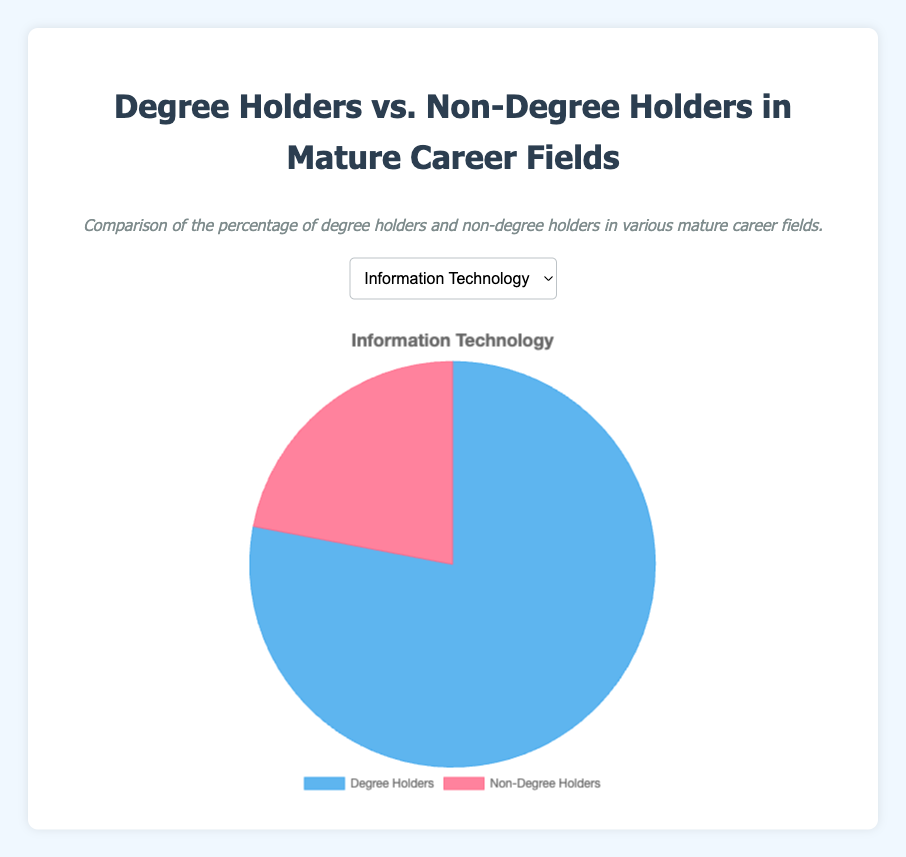What percentage of degree holders is higher in Healthcare compared to Construction? Healthcare has 85% degree holders, whereas Construction has 40%. The difference is 85% - 40% = 45%.
Answer: 45% Which career field has the highest percentage of non-degree holders? By comparing the non-degree holder percentages: Information Technology (22%), Manufacturing (35%), Healthcare (15%), Finance (20%), and Construction (60%), Construction has the highest percentage.
Answer: Construction How much higher is the percentage of non-degree holders in Manufacturing compared to Healthcare? The percentage of non-degree holders in Manufacturing is 35%, and in Healthcare, it is 15%. The difference is 35% - 15% = 20%.
Answer: 20% What is the average percentage of degree holders across all five career fields? Calculate the average by summing the percentages and dividing by the number of fields: (78 + 65 + 85 + 80 + 40) / 5 = 348 / 5 = 69.6.
Answer: 69.6% By what factor is the percentage of degree holders in Finance greater than that in Construction? The percentage of degree holders in Finance is 80%, and in Construction, it is 40%. The factor is 80% / 40% = 2.
Answer: 2 Which two career fields have the closest percentage of degree holders? Comparing the degree holder percentages: Information Technology (78%), Manufacturing (65%), Healthcare (85%), Finance (80%), and Construction (40%), the closest percentages are Information Technology (78%) and Finance (80%).
Answer: Information Technology and Finance If a career field is selected at random, which is more likely to have a higher percentage of degree holders: Healthcare or Finance? Healthcare has a higher percentage of degree holders (85%) compared to Finance (80%).
Answer: Healthcare How does the color representation of degree holders differ visually from non-degree holders in the chart? Degree holders are represented by a shade of blue, whereas non-degree holders are represented by a shade of red.
Answer: Blue and Red What is the combined percentage of degree holders in both Information Technology and Finance? The percentage of degree holders in Information Technology is 78%, and in Finance, it is 80%. The combined percentage is 78% + 80% = 158%.
Answer: 158% Considering the data, is it accurate to say that degree holders usually make up more than half of the workforce in mature career fields? Except for Construction (40%), the other fields have degree holders comprising 65% (Manufacturing) to 85% (Healthcare), hence it is accurate to say degree holders usually make up more than half.
Answer: Yes 